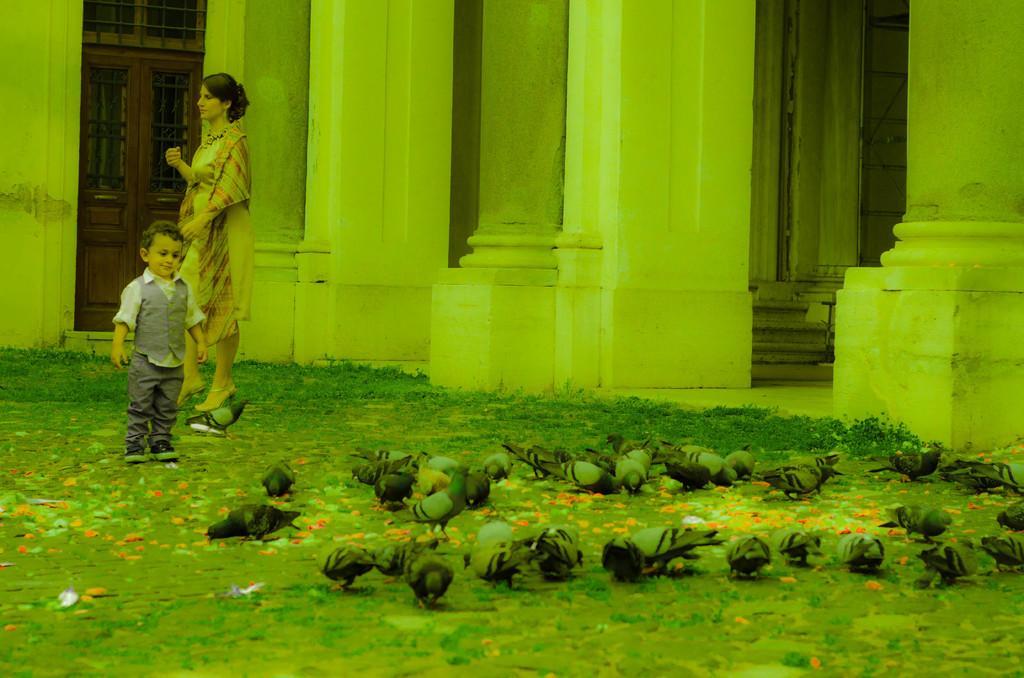Describe this image in one or two sentences. In this image we can see pigeons and persons standing on the ground. In the background there are stairs, pillars and door with grills. 